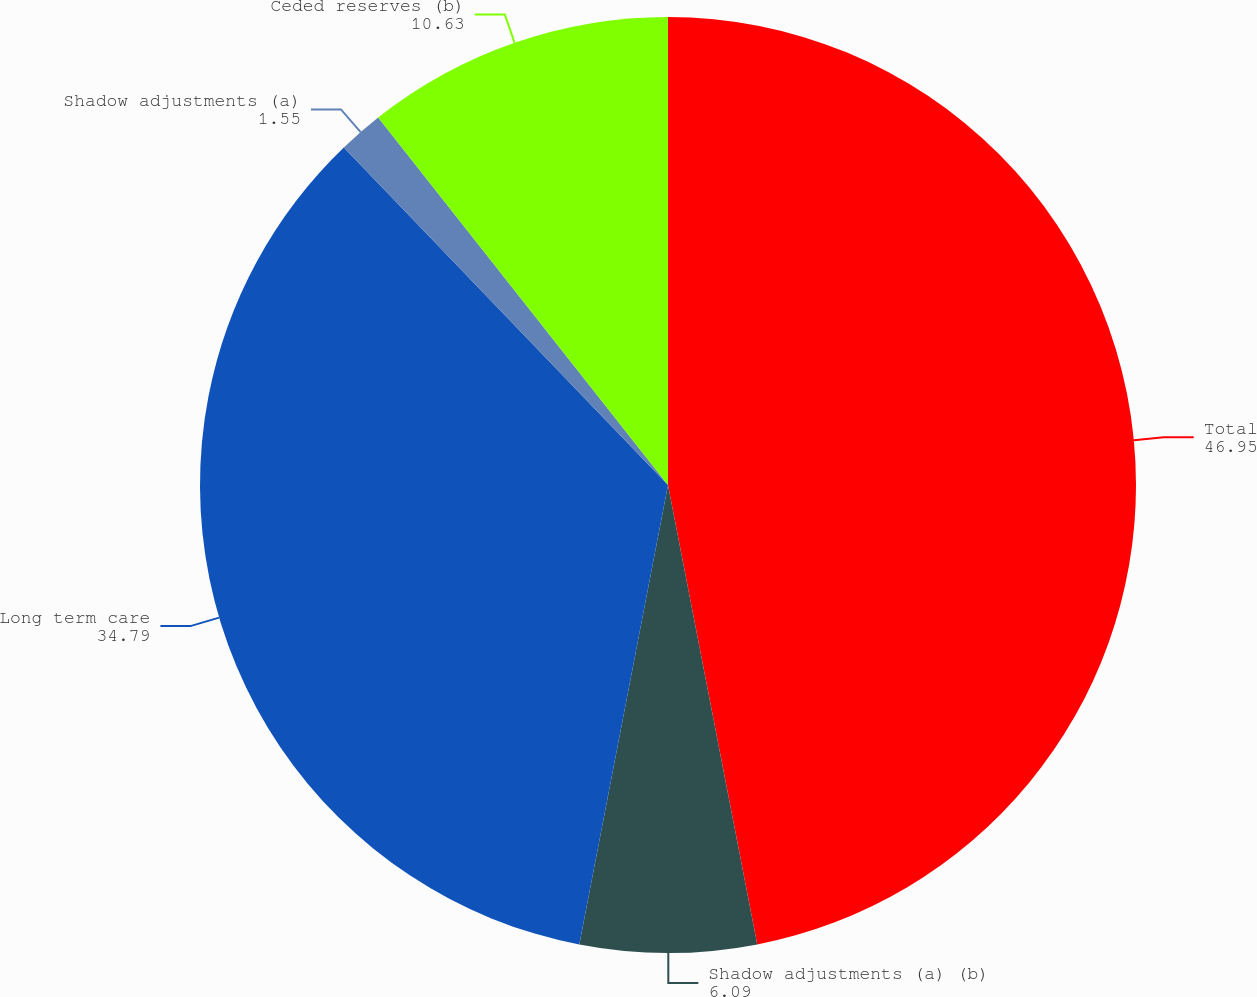Convert chart to OTSL. <chart><loc_0><loc_0><loc_500><loc_500><pie_chart><fcel>Total<fcel>Shadow adjustments (a) (b)<fcel>Long term care<fcel>Shadow adjustments (a)<fcel>Ceded reserves (b)<nl><fcel>46.95%<fcel>6.09%<fcel>34.79%<fcel>1.55%<fcel>10.63%<nl></chart> 